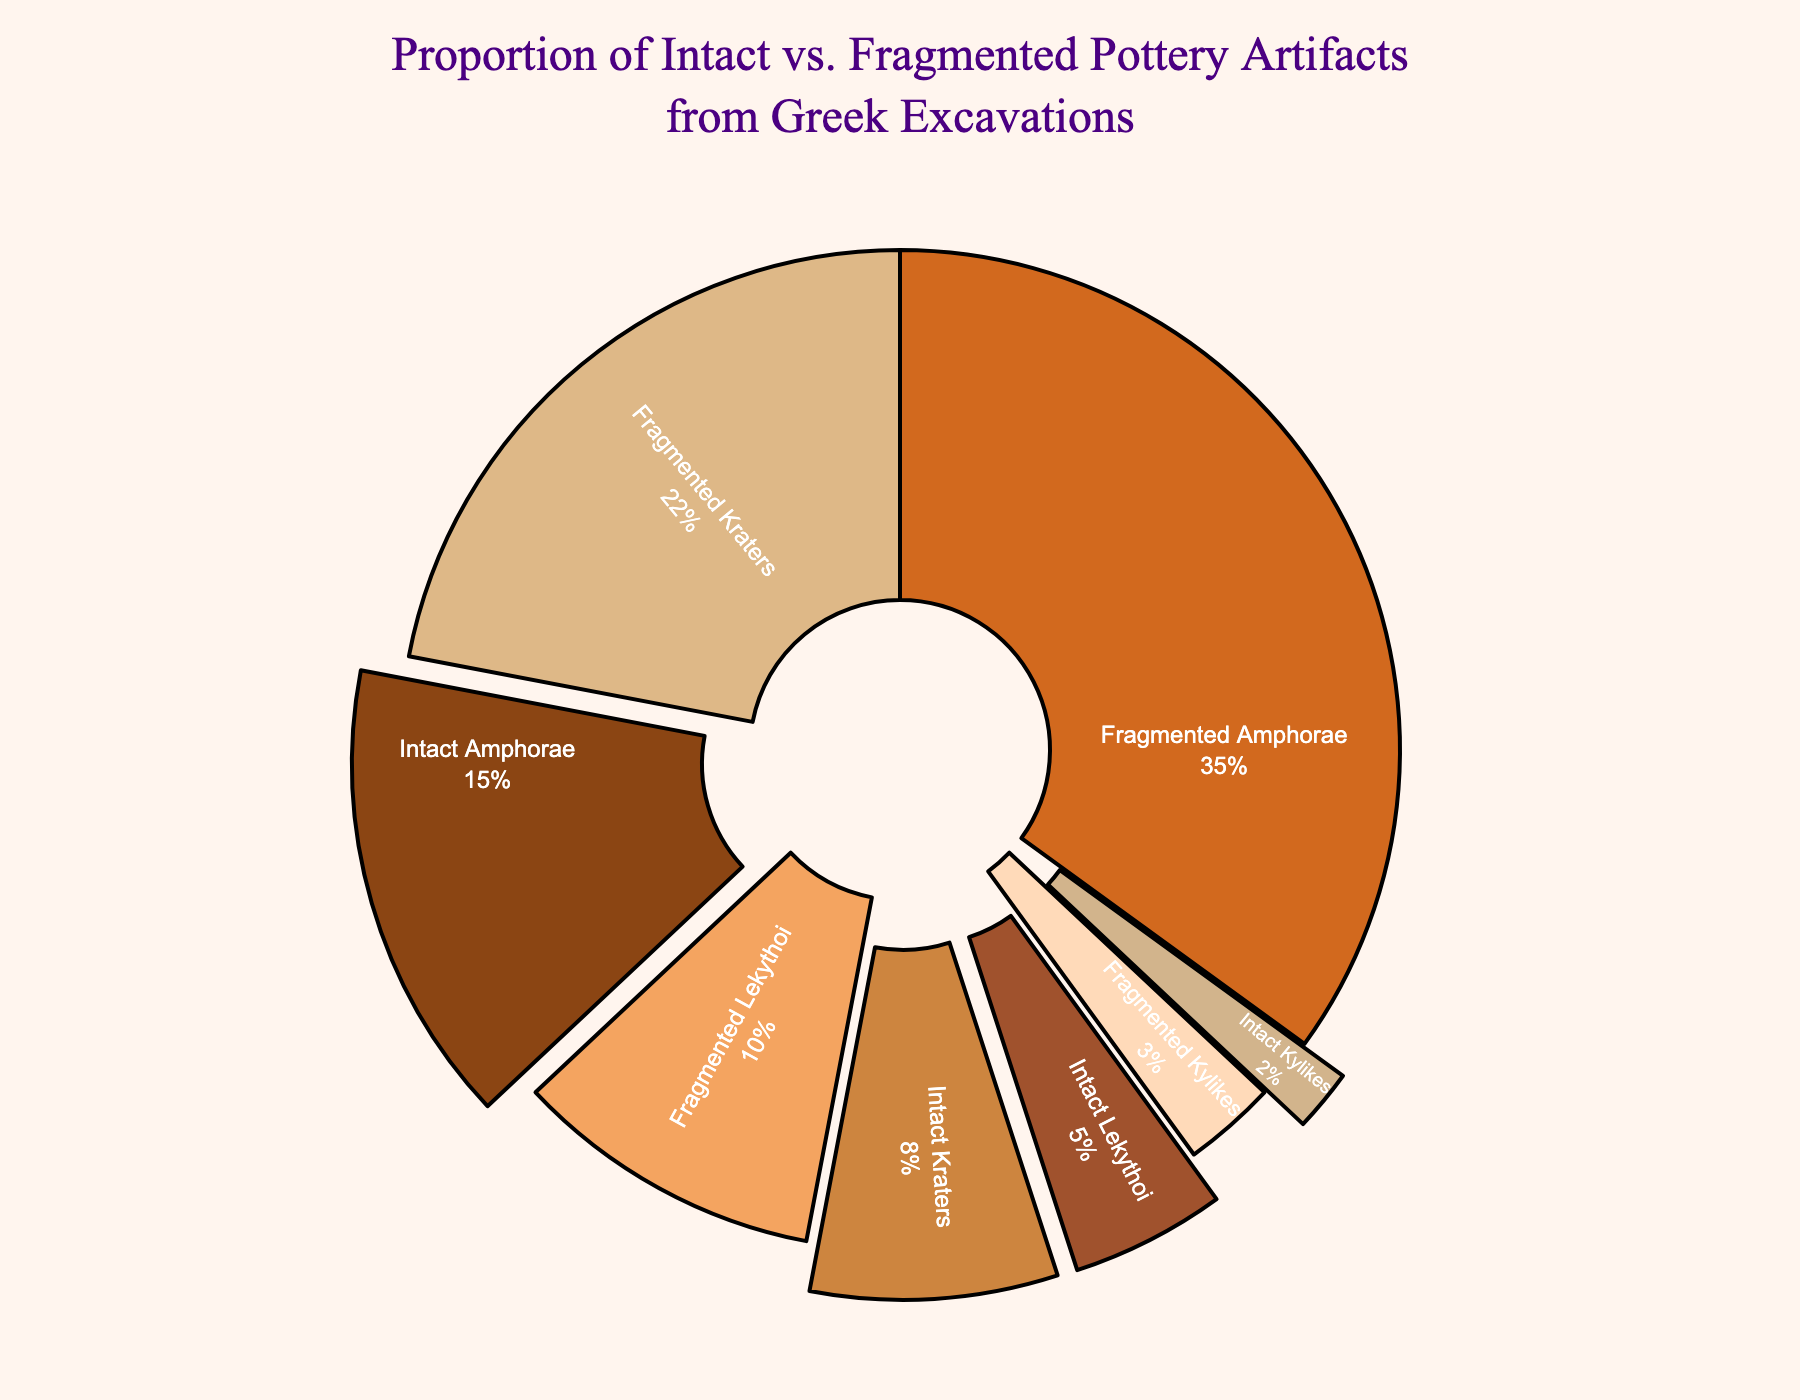What is the total percentage of fragmented artifacts? Start by identifying the fragmented artifacts: Fragmented Amphorae (35%), Fragmented Kraters (22%), Fragmented Lekythoi (10%), and Fragmented Kylikes (3%). Sum these percentages: 35 + 22 + 10 + 3 = 70%.
Answer: 70% Which artifact type has the highest percentage of intact pieces? Compare the percentages of intact pieces: Intact Amphorae (15%), Intact Kraters (8%), Intact Lekythoi (5%), and Intact Kylikes (2%). Intact Amphorae has the highest percentage (15%).
Answer: Amphorae Are there more fragmented Kraters or fragmented Lekythoi? Compare the percentages of fragmented Kraters (22%) and fragmented Lekythoi (10%). 22% is greater than 10%.
Answer: Fragmented Kraters What is the ratio of intact Amphorae to fragmented Amphorae? The percentage of intact Amphorae is 15%, and the percentage of fragmented Amphorae is 35%. The ratio is 15:35. Simplify by dividing both numbers by 5: 3:7.
Answer: 3:7 How much smaller is the percentage of intact Kylikes compared to fragmented Kylikes? Subtract the percentage of intact Kylikes (2%) from the percentage of fragmented Kylikes (3%): 3 - 2 = 1%.
Answer: 1% What is the combined percentage of intact and fragmented Kraters? Sum the percentage of intact Kraters (8%) and fragmented Kraters (22%): 8 + 22 = 30%.
Answer: 30% Which artifact type has the smallest total representation (intact + fragmented)? Sum intact and fragmented percentages for each artifact type: Amphorae (15 + 35), Kraters (8 + 22), Lekythoi (5 + 10), Kylikes (2 + 3). Amphorae: 50%, Kraters: 30%, Lekythoi: 15%, Kylikes: 5%. Kylikes have the smallest total representation (5%).
Answer: Kylikes What percentage of the chart do the intact artifacts constitute in total? Sum the percentages of intact artifacts: Intact Amphorae (15%), Intact Kraters (8%), Intact Lekythoi (5%), and Intact Kylikes (2%): 15 + 8 + 5 + 2 = 30%.
Answer: 30% Which has a higher percentage: intact Lekythoi or fragmented Kylikes? Compare the percentages of intact Lekythoi (5%) and fragmented Kylikes (3%). 5% is greater than 3%.
Answer: Intact Lekythoi What is the difference in the percentage of intact Amphorae and intact Kraters? Subtract the percentage of intact Kraters (8%) from intact Amphorae (15%): 15 - 8 = 7%.
Answer: 7% 